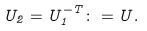Convert formula to latex. <formula><loc_0><loc_0><loc_500><loc_500>U _ { 2 } = U _ { 1 } ^ { - T } \colon = U .</formula> 